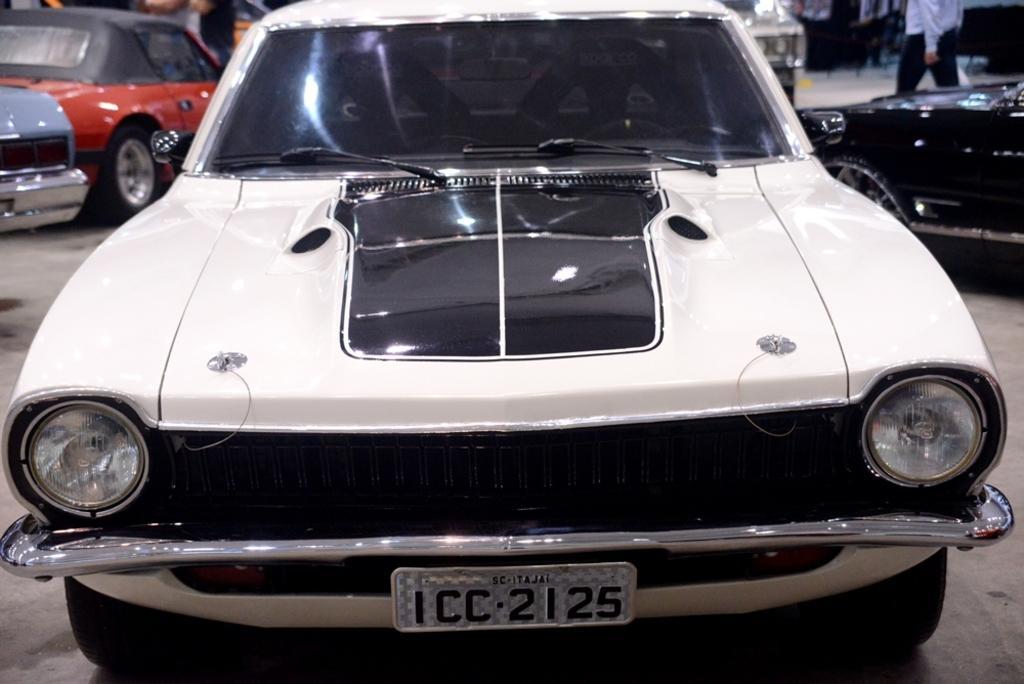Can you describe this image briefly? In this picture there is a car in the center of the image, which is white in color and there are other cars and people in the background area of the image. 